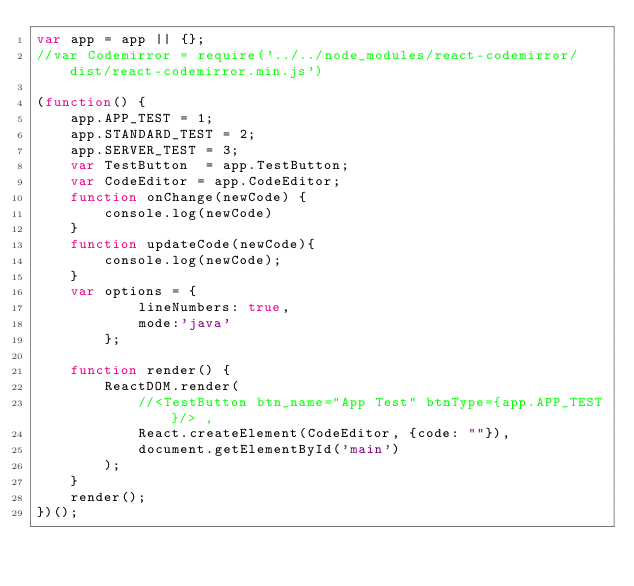<code> <loc_0><loc_0><loc_500><loc_500><_JavaScript_>var app = app || {};
//var Codemirror = require('../../node_modules/react-codemirror/dist/react-codemirror.min.js')

(function() {
    app.APP_TEST = 1;
    app.STANDARD_TEST = 2;
    app.SERVER_TEST = 3;
    var TestButton  = app.TestButton;  
    var CodeEditor = app.CodeEditor; 
    function onChange(newCode) {
        console.log(newCode)
    }
    function updateCode(newCode){
        console.log(newCode);
    }
    var options = {
            lineNumbers: true,
            mode:'java'
        };

    function render() {
        ReactDOM.render( 
            //<TestButton btn_name="App Test" btnType={app.APP_TEST}/> ,
            React.createElement(CodeEditor, {code: ""}),
            document.getElementById('main')
        );
    }
    render();
})();</code> 